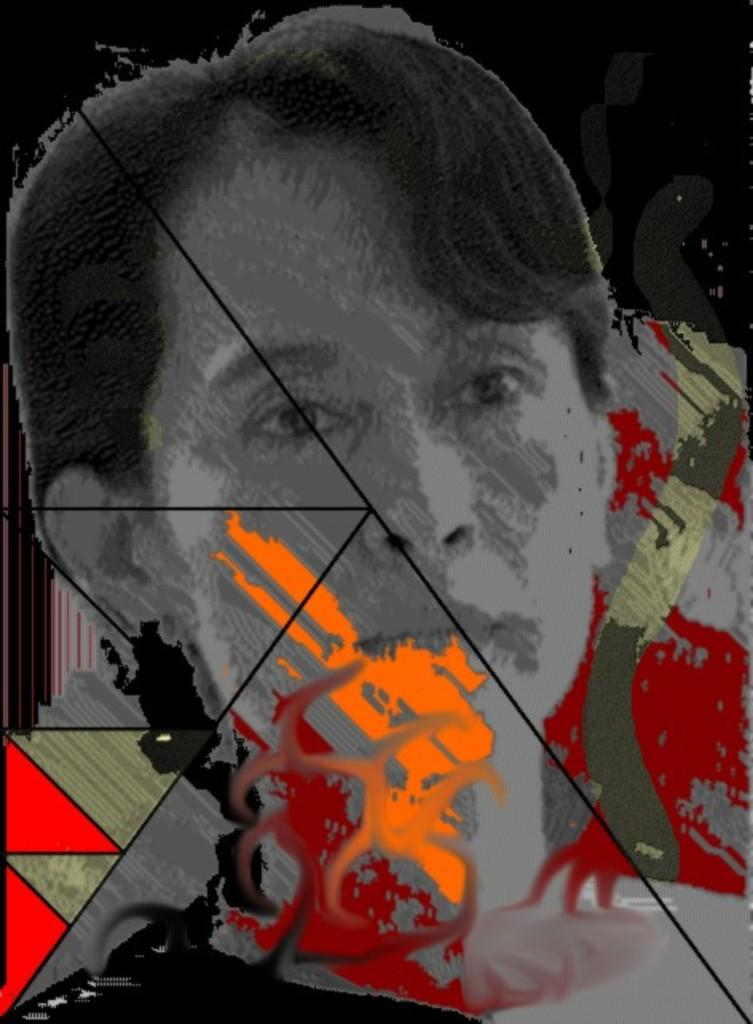What is the main subject of the image? There is a person's face in the image. Can you describe the colors present in the image? The image contains various colors, including red, grey, orange, and yellow. What color is the background of the image? The background of the image is black. What statement does the person make in the image? There is no statement being made by the person in the image, as it only shows their face. What is the current temperature in the image? The image does not provide any information about the temperature, as it only shows a person's face and colors. 